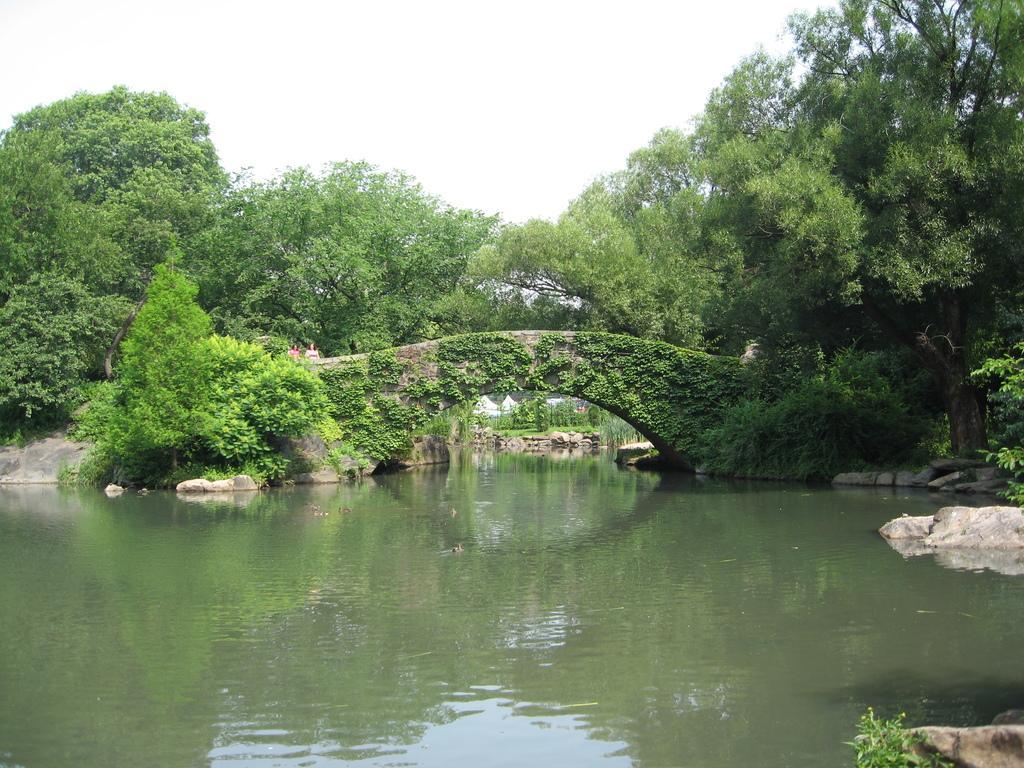Could you give a brief overview of what you see in this image? This is water, in the middle it is a bridge and there are green trees. At the top it's a sky. 